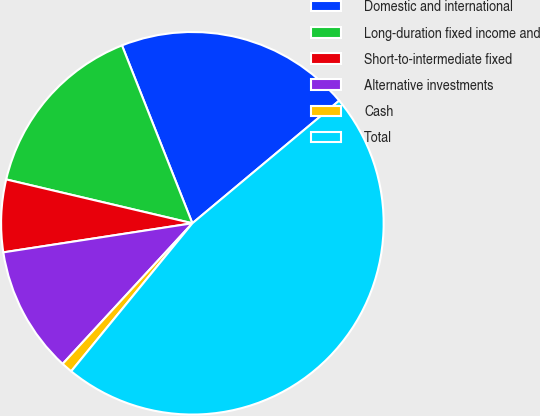<chart> <loc_0><loc_0><loc_500><loc_500><pie_chart><fcel>Domestic and international<fcel>Long-duration fixed income and<fcel>Short-to-intermediate fixed<fcel>Alternative investments<fcel>Cash<fcel>Total<nl><fcel>19.92%<fcel>15.32%<fcel>6.11%<fcel>10.71%<fcel>0.94%<fcel>46.99%<nl></chart> 